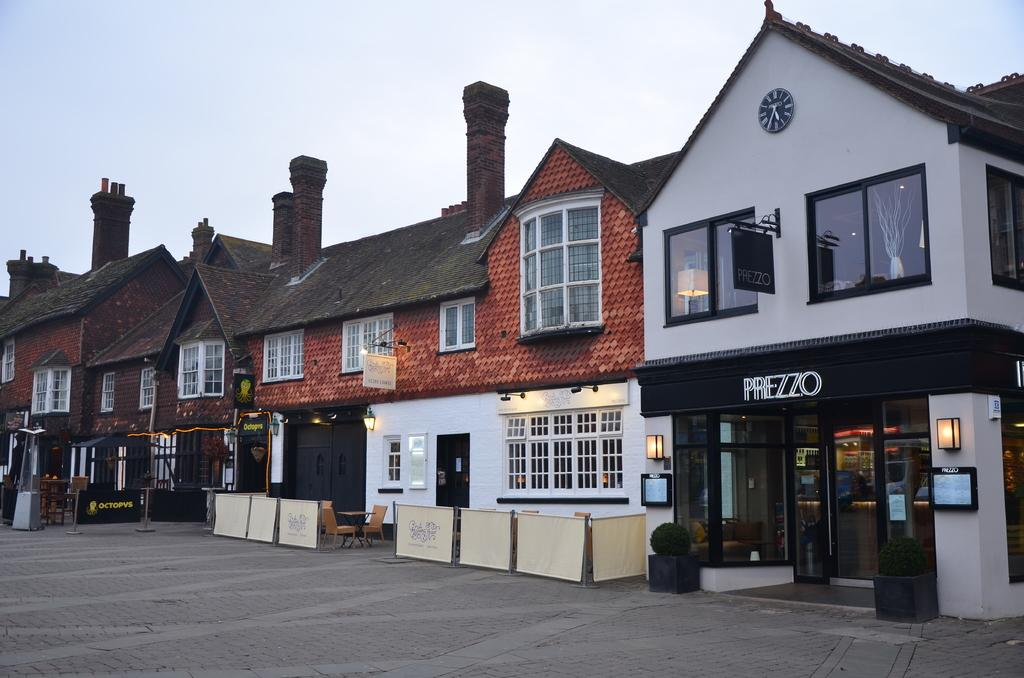What type of structures can be seen in the image? There are buildings in the image. What type of establishments can be found within these structures? There are stores in the image. How can the stores be identified in the image? Name boards are present in the image. What type of lighting is visible in the image? Electric lights are visible in the image. What type of furniture is present in the image? Chairs and tables are present in the image. What type of greenery is visible in the image? House plants are visible in the image. What part of the natural environment is visible in the image? The sky is visible in the image. Can you describe the shape of the volcano in the image? There is no volcano present in the image. What type of advice does the grandfather give in the image? There is no grandfather present in the image, so it is not possible to answer that question. 